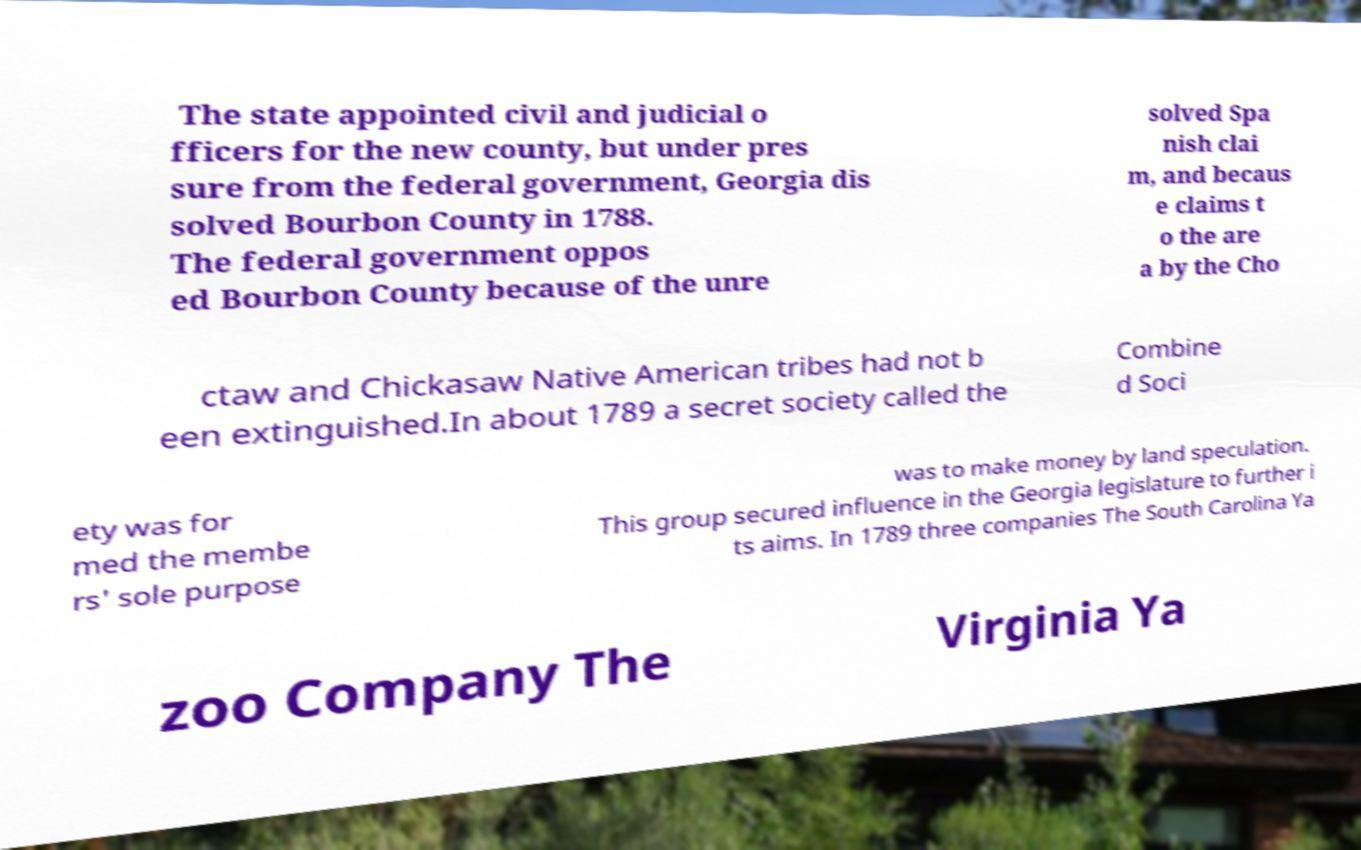Can you accurately transcribe the text from the provided image for me? The state appointed civil and judicial o fficers for the new county, but under pres sure from the federal government, Georgia dis solved Bourbon County in 1788. The federal government oppos ed Bourbon County because of the unre solved Spa nish clai m, and becaus e claims t o the are a by the Cho ctaw and Chickasaw Native American tribes had not b een extinguished.In about 1789 a secret society called the Combine d Soci ety was for med the membe rs' sole purpose was to make money by land speculation. This group secured influence in the Georgia legislature to further i ts aims. In 1789 three companies The South Carolina Ya zoo Company The Virginia Ya 